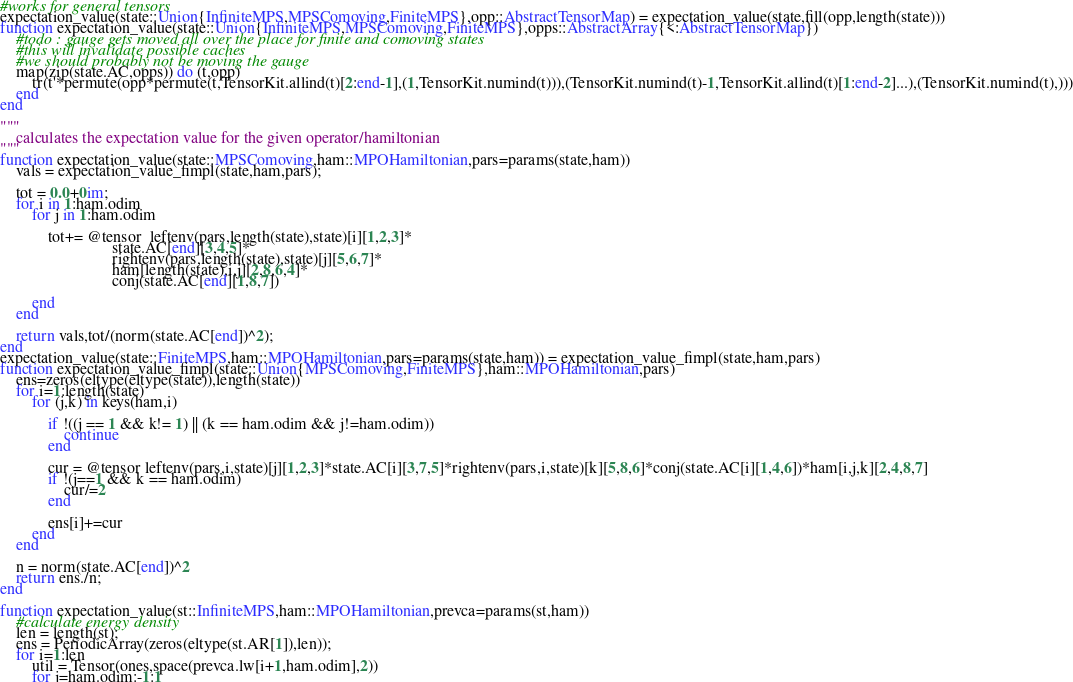Convert code to text. <code><loc_0><loc_0><loc_500><loc_500><_Julia_>#works for general tensors
expectation_value(state::Union{InfiniteMPS,MPSComoving,FiniteMPS},opp::AbstractTensorMap) = expectation_value(state,fill(opp,length(state)))
function expectation_value(state::Union{InfiniteMPS,MPSComoving,FiniteMPS},opps::AbstractArray{<:AbstractTensorMap})
    #todo : gauge gets moved all over the place for finite and comoving states
    #this will invalidate possible caches
    #we should probably not be moving the gauge
    map(zip(state.AC,opps)) do (t,opp)
        tr(t'*permute(opp*permute(t,TensorKit.allind(t)[2:end-1],(1,TensorKit.numind(t))),(TensorKit.numind(t)-1,TensorKit.allind(t)[1:end-2]...),(TensorKit.numind(t),)))
    end
end

"""
    calculates the expectation value for the given operator/hamiltonian
"""
function expectation_value(state::MPSComoving,ham::MPOHamiltonian,pars=params(state,ham))
    vals = expectation_value_fimpl(state,ham,pars);

    tot = 0.0+0im;
    for i in 1:ham.odim
        for j in 1:ham.odim

            tot+= @tensor  leftenv(pars,length(state),state)[i][1,2,3]*
                            state.AC[end][3,4,5]*
                            rightenv(pars,length(state),state)[j][5,6,7]*
                            ham[length(state),i,j][2,8,6,4]*
                            conj(state.AC[end][1,8,7])

        end
    end

    return vals,tot/(norm(state.AC[end])^2);
end
expectation_value(state::FiniteMPS,ham::MPOHamiltonian,pars=params(state,ham)) = expectation_value_fimpl(state,ham,pars)
function expectation_value_fimpl(state::Union{MPSComoving,FiniteMPS},ham::MPOHamiltonian,pars)
    ens=zeros(eltype(eltype(state)),length(state))
    for i=1:length(state)
        for (j,k) in keys(ham,i)

            if !((j == 1 && k!= 1) || (k == ham.odim && j!=ham.odim))
                continue
            end

            cur = @tensor leftenv(pars,i,state)[j][1,2,3]*state.AC[i][3,7,5]*rightenv(pars,i,state)[k][5,8,6]*conj(state.AC[i][1,4,6])*ham[i,j,k][2,4,8,7]
            if !(j==1 && k == ham.odim)
                cur/=2
            end

            ens[i]+=cur
        end
    end

    n = norm(state.AC[end])^2
    return ens./n;
end

function expectation_value(st::InfiniteMPS,ham::MPOHamiltonian,prevca=params(st,ham))
    #calculate energy density
    len = length(st);
    ens = PeriodicArray(zeros(eltype(st.AR[1]),len));
    for i=1:len
        util = Tensor(ones,space(prevca.lw[i+1,ham.odim],2))
        for j=ham.odim:-1:1</code> 